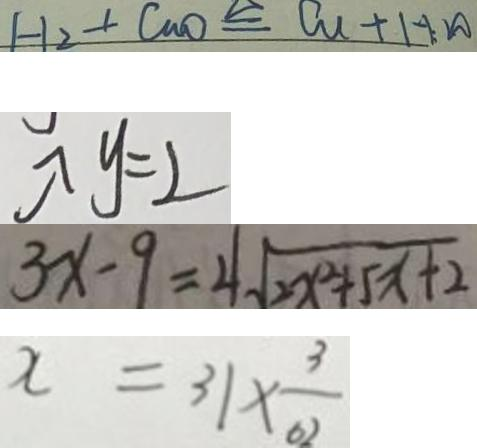<formula> <loc_0><loc_0><loc_500><loc_500>H _ { 2 } + C u O \xlongequal { \Delta } C u + H _ { 2 } O 
 \uparrow y = 2 
 3 x - 9 = 4 \sqrt { 2 x ^ { 2 } + 5 x + 2 } 
 x = 3 1 \times \frac { 3 } { 6 2 }</formula> 